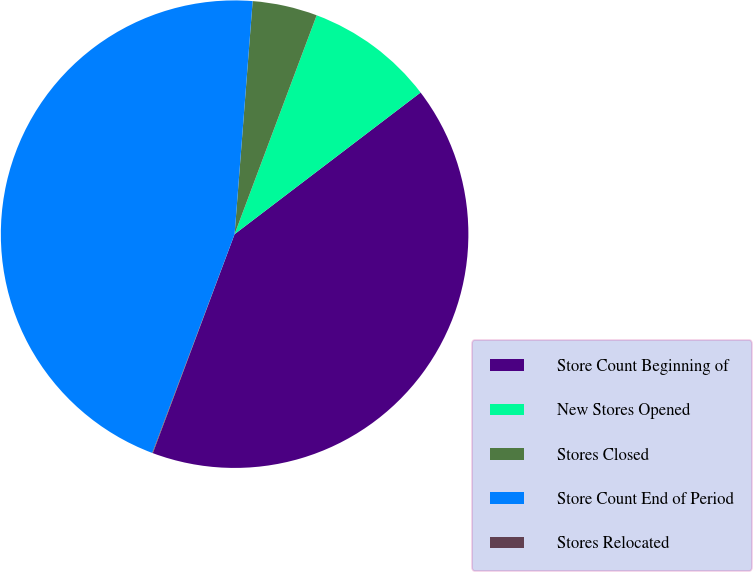Convert chart to OTSL. <chart><loc_0><loc_0><loc_500><loc_500><pie_chart><fcel>Store Count Beginning of<fcel>New Stores Opened<fcel>Stores Closed<fcel>Store Count End of Period<fcel>Stores Relocated<nl><fcel>41.05%<fcel>8.93%<fcel>4.48%<fcel>45.5%<fcel>0.04%<nl></chart> 